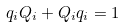Convert formula to latex. <formula><loc_0><loc_0><loc_500><loc_500>q _ { i } Q _ { i } + Q _ { i } q _ { i } = 1</formula> 